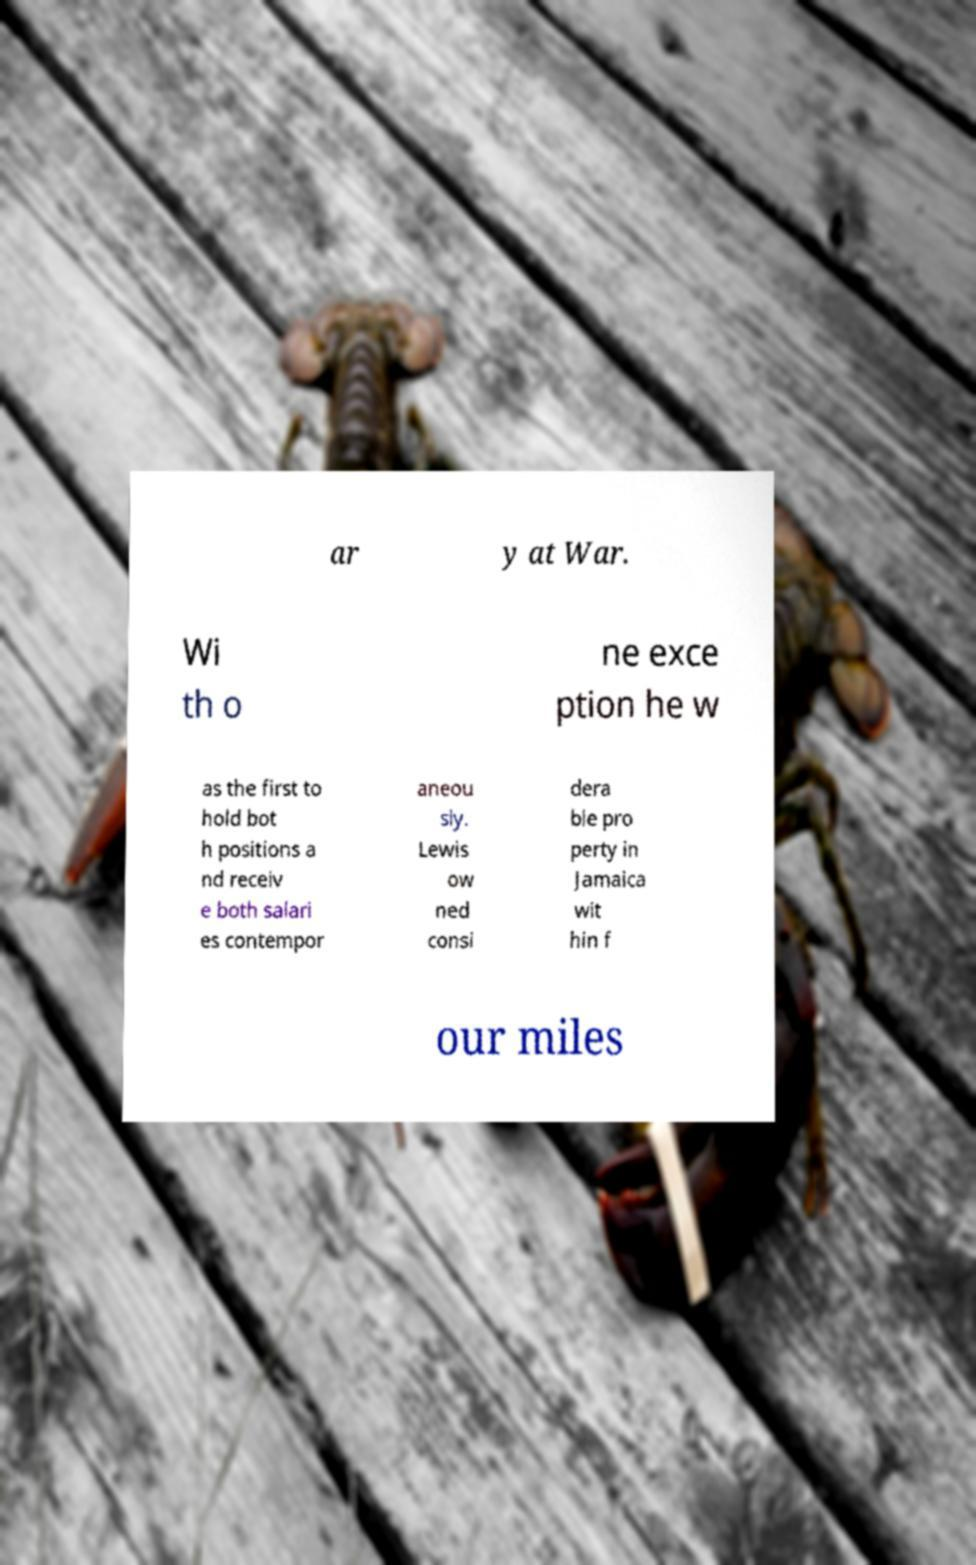I need the written content from this picture converted into text. Can you do that? ar y at War. Wi th o ne exce ption he w as the first to hold bot h positions a nd receiv e both salari es contempor aneou sly. Lewis ow ned consi dera ble pro perty in Jamaica wit hin f our miles 